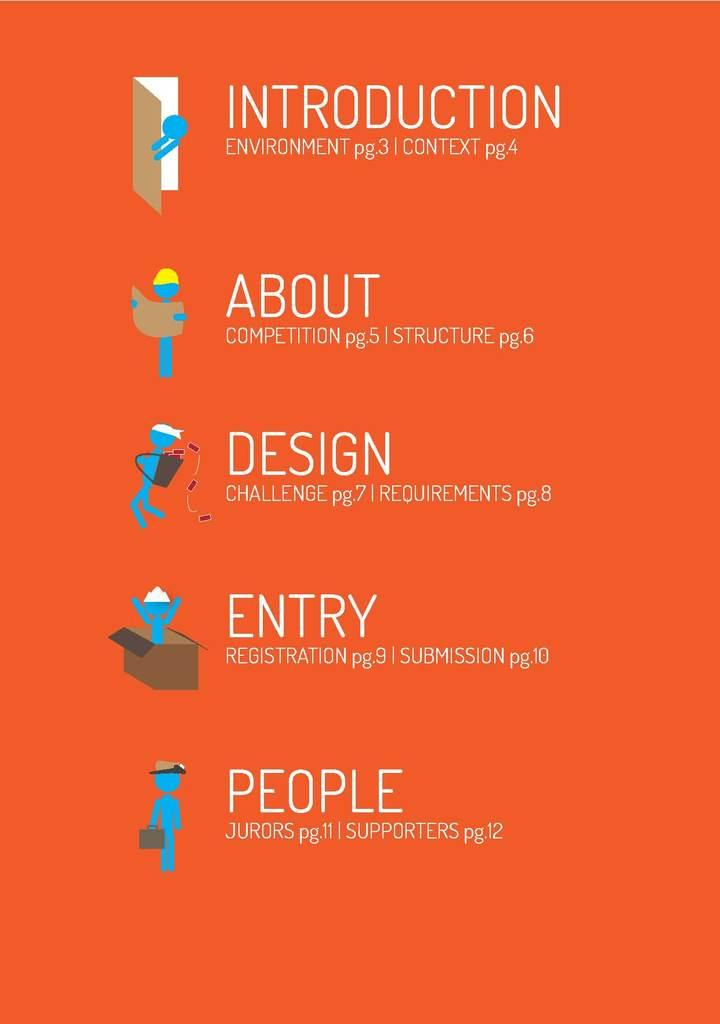<image>
Create a compact narrative representing the image presented. An orange and very decorated content page with icons. 